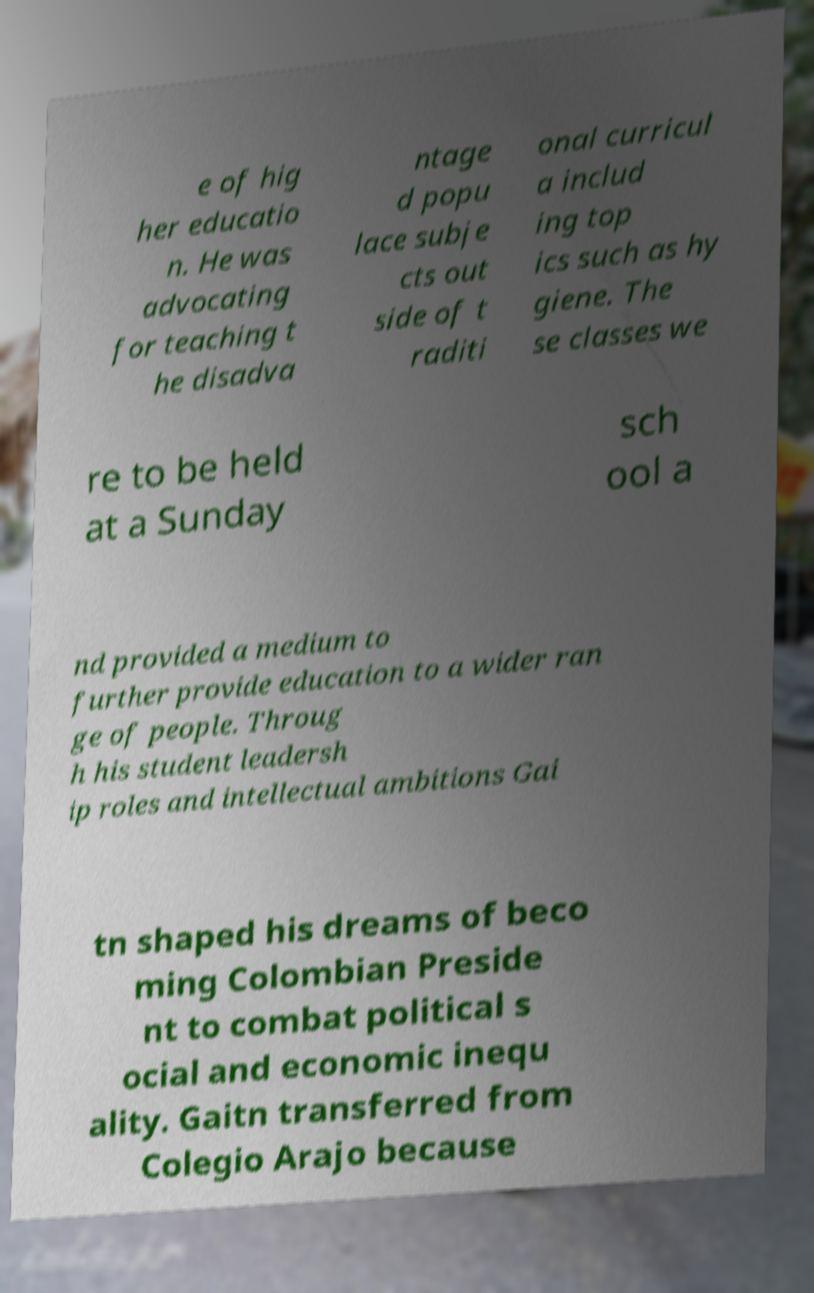Please identify and transcribe the text found in this image. e of hig her educatio n. He was advocating for teaching t he disadva ntage d popu lace subje cts out side of t raditi onal curricul a includ ing top ics such as hy giene. The se classes we re to be held at a Sunday sch ool a nd provided a medium to further provide education to a wider ran ge of people. Throug h his student leadersh ip roles and intellectual ambitions Gai tn shaped his dreams of beco ming Colombian Preside nt to combat political s ocial and economic inequ ality. Gaitn transferred from Colegio Arajo because 